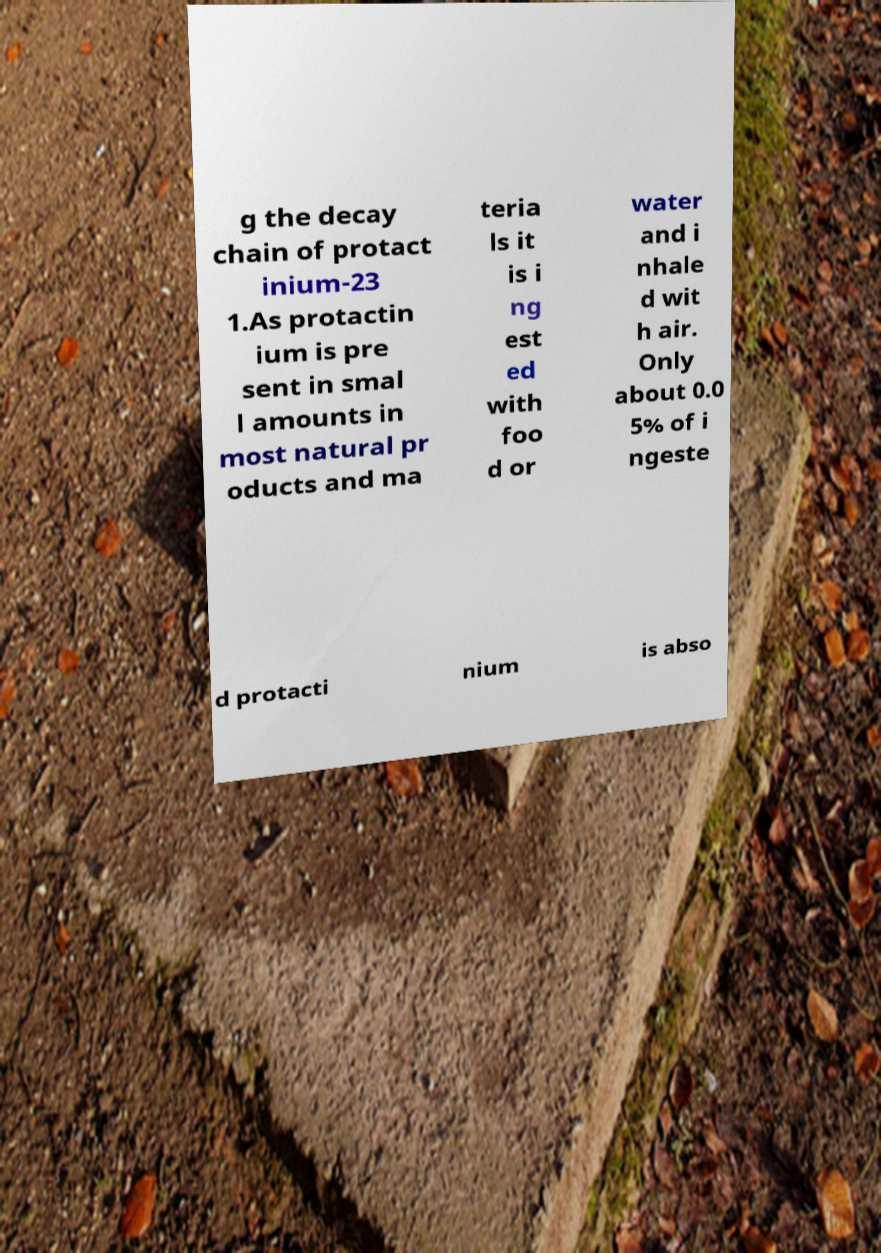There's text embedded in this image that I need extracted. Can you transcribe it verbatim? g the decay chain of protact inium-23 1.As protactin ium is pre sent in smal l amounts in most natural pr oducts and ma teria ls it is i ng est ed with foo d or water and i nhale d wit h air. Only about 0.0 5% of i ngeste d protacti nium is abso 